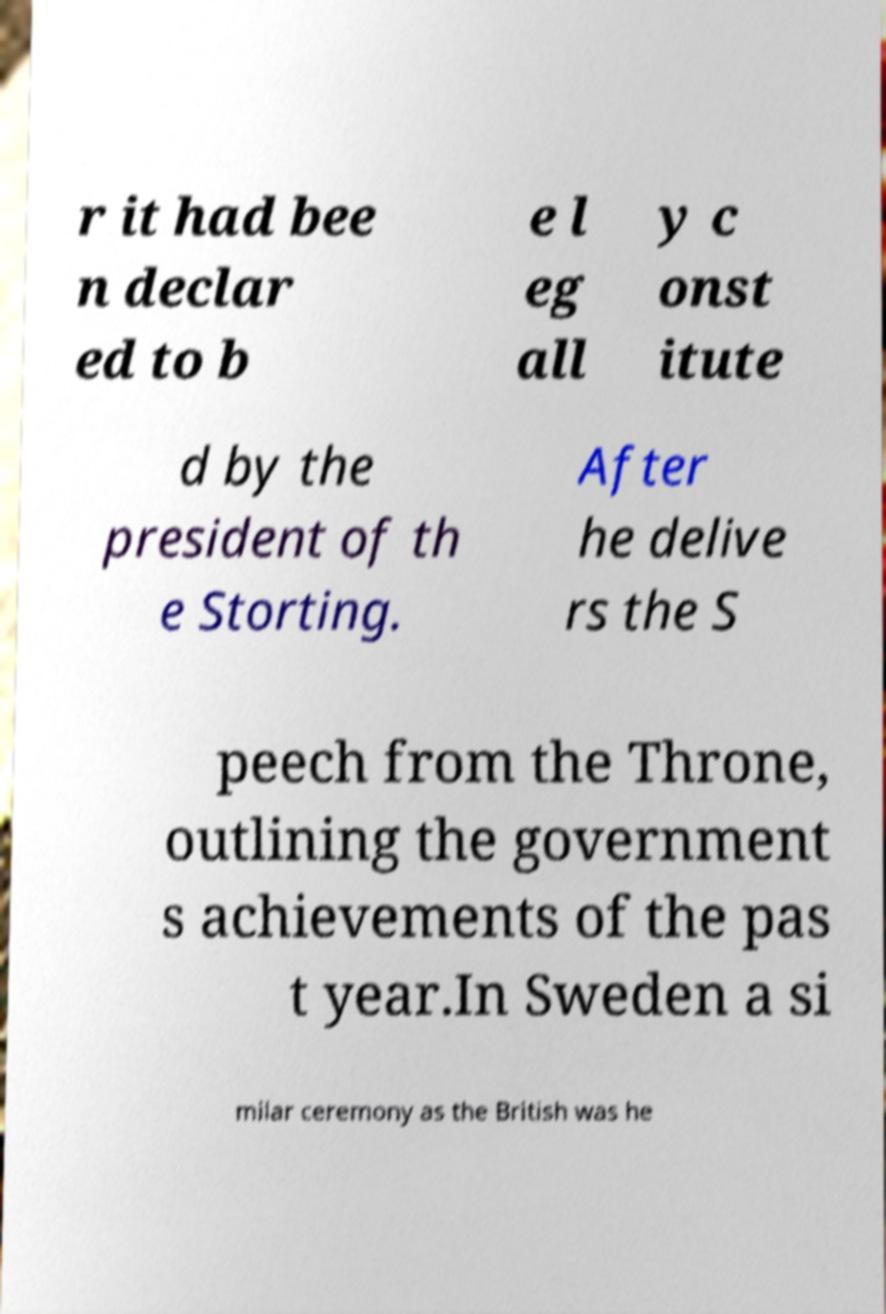Can you read and provide the text displayed in the image?This photo seems to have some interesting text. Can you extract and type it out for me? r it had bee n declar ed to b e l eg all y c onst itute d by the president of th e Storting. After he delive rs the S peech from the Throne, outlining the government s achievements of the pas t year.In Sweden a si milar ceremony as the British was he 